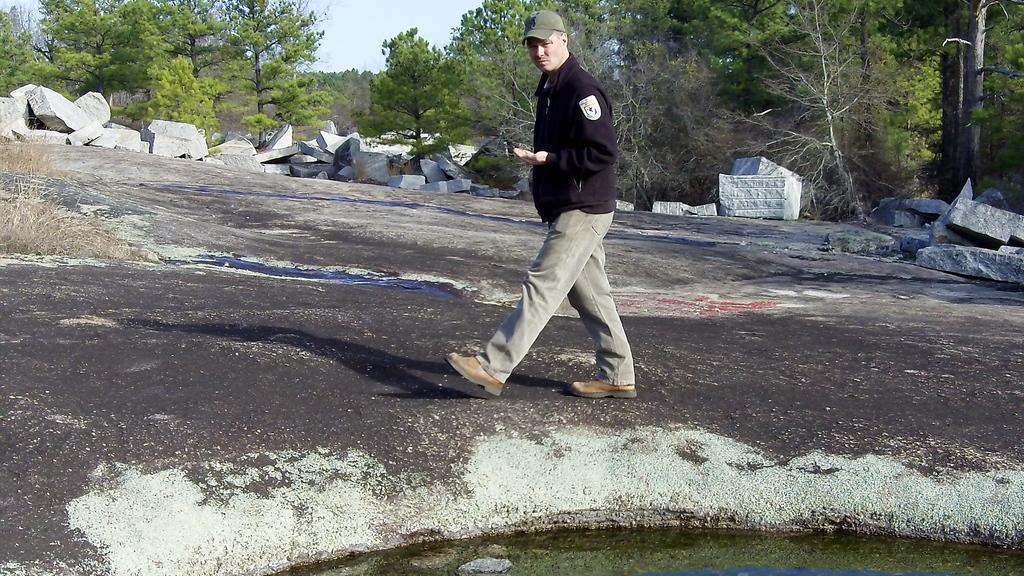Please provide a concise description of this image. In the middle of the image a man is walking. Behind him there are some stones and trees. Bottom of the image there is water. 